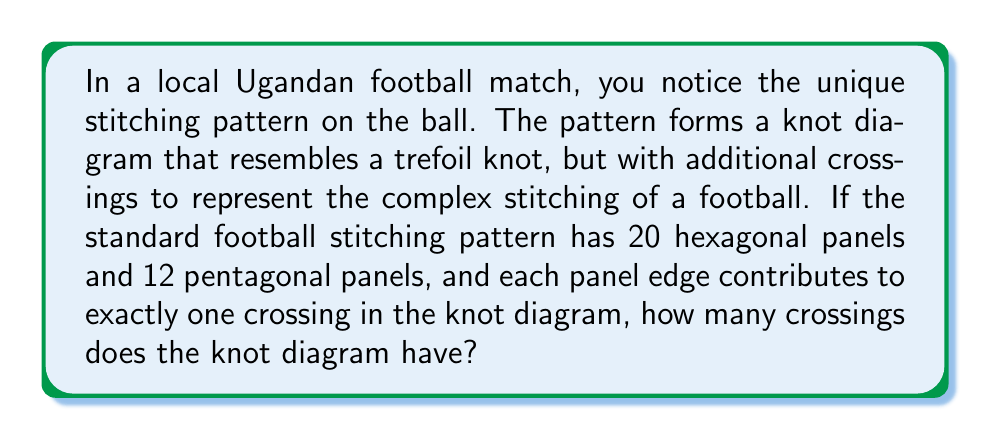Give your solution to this math problem. Let's approach this step-by-step:

1) First, we need to calculate the total number of panel edges:
   - Each hexagon has 6 edges
   - Each pentagon has 5 edges
   - Total edges = $(20 \times 6) + (12 \times 5) = 120 + 60 = 180$

2) However, each edge is shared by two panels, so we need to divide this number by 2:
   $$\text{Number of unique edges} = \frac{180}{2} = 90$$

3) Now, we're told that each panel edge contributes to exactly one crossing in the knot diagram. This means that the number of crossings is equal to the number of unique edges.

4) Therefore, the knot diagram representing the football's stitching pattern has 90 crossings.

This high number of crossings reflects the complexity of a football's stitching pattern, which ensures the ball's structural integrity and consistent shape, crucial for fair play in local Ugandan matches and worldwide.
Answer: 90 crossings 